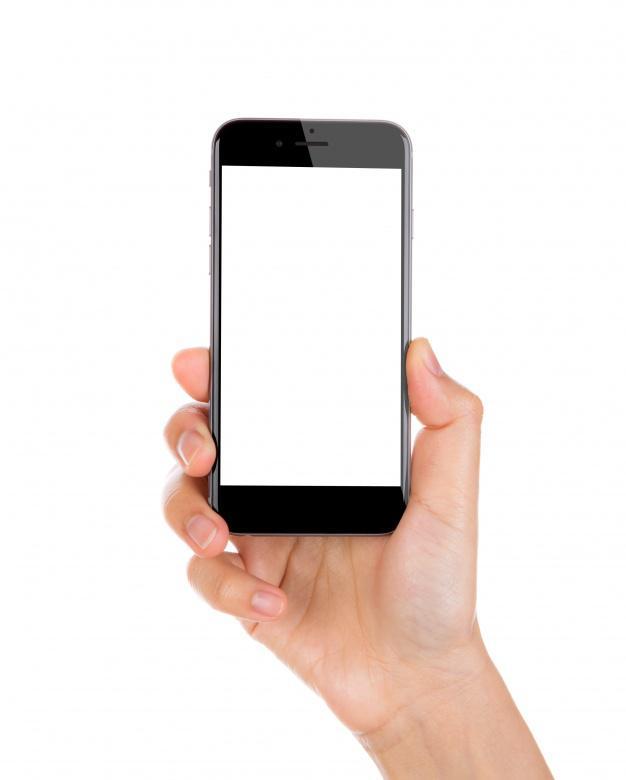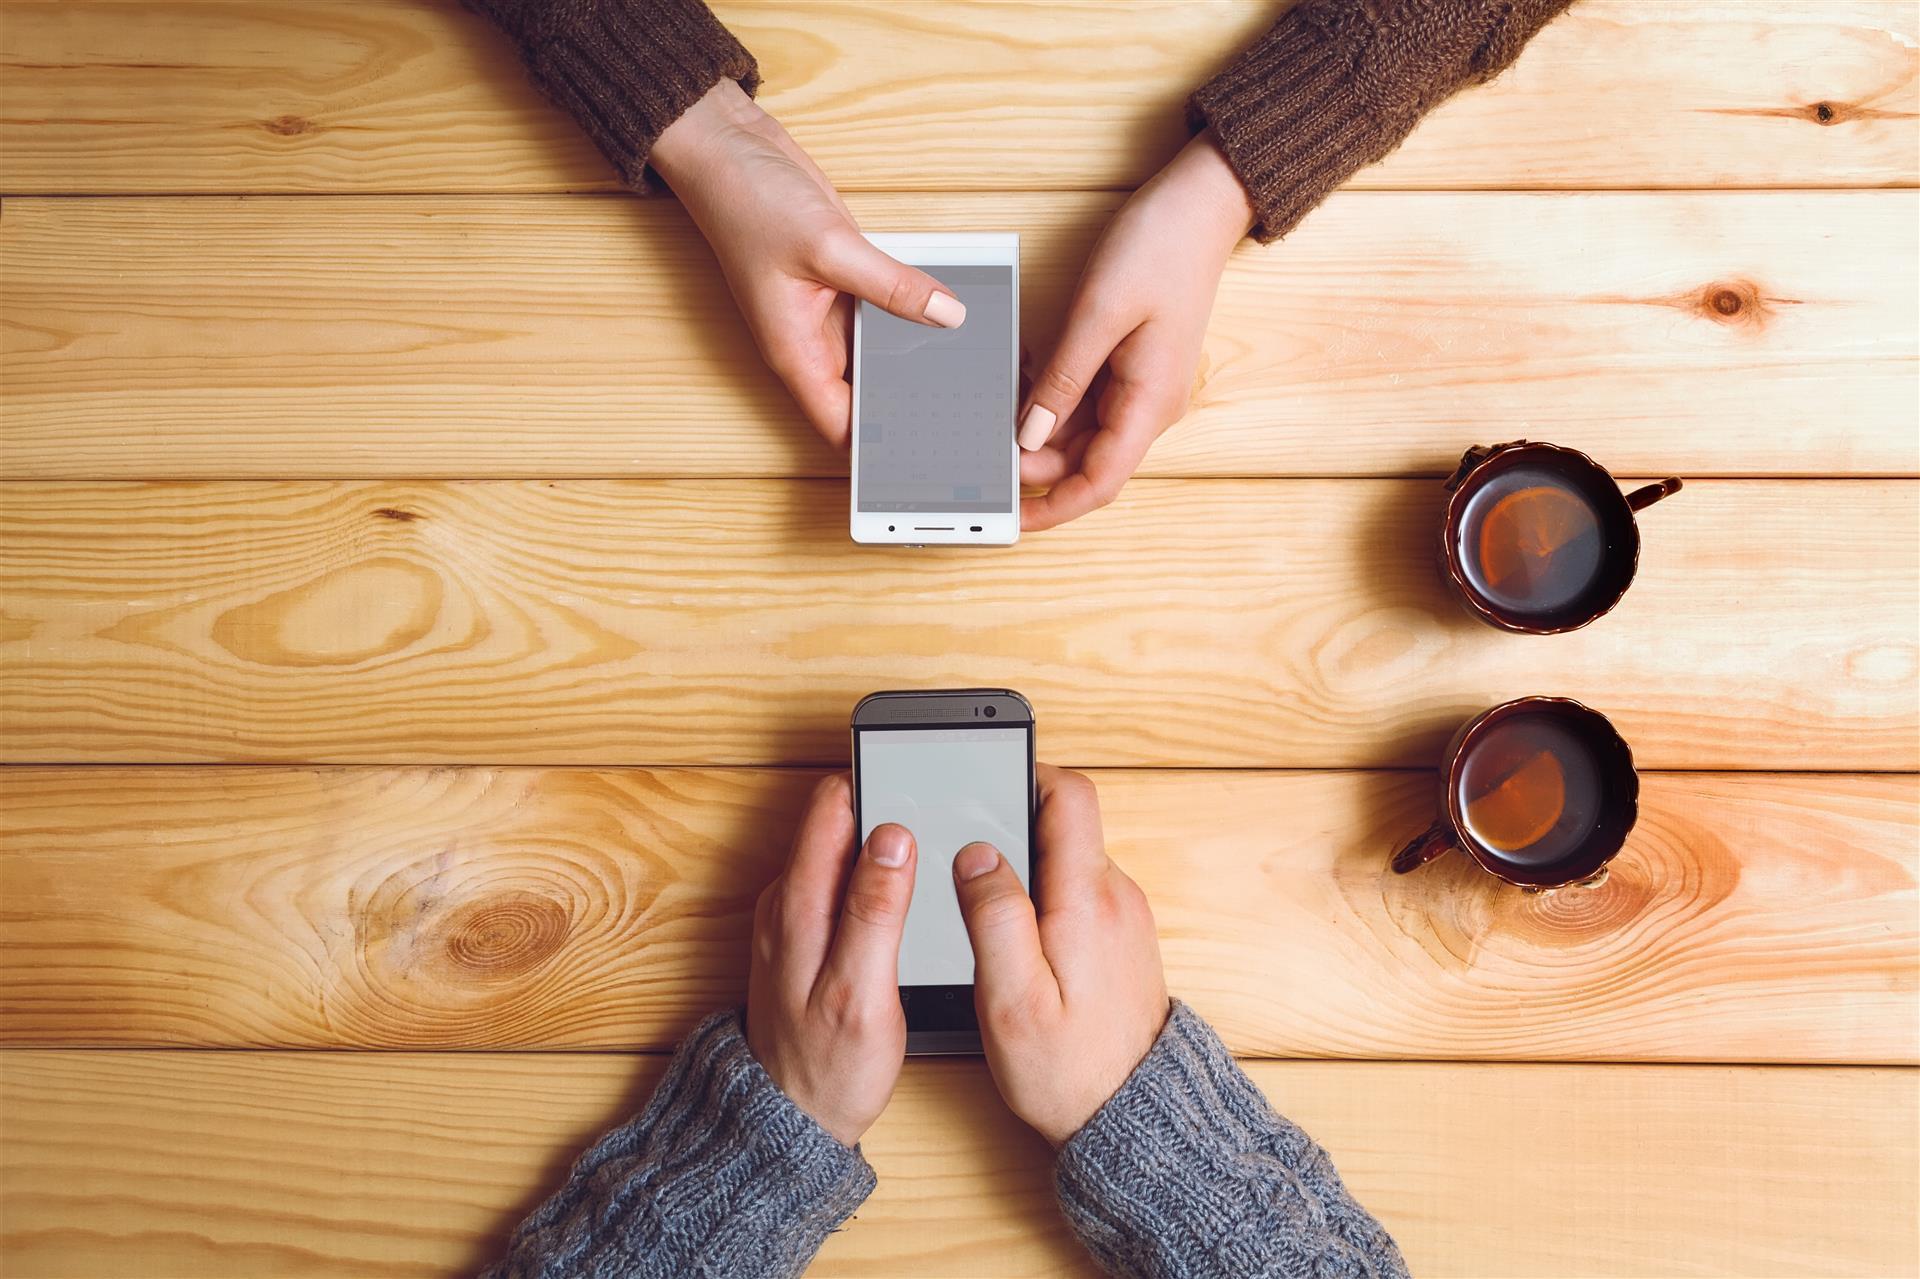The first image is the image on the left, the second image is the image on the right. Evaluate the accuracy of this statement regarding the images: "A single hand is holding a phone upright and head-on in one image, and the other image includes hands reaching in from opposite sides.". Is it true? Answer yes or no. Yes. 